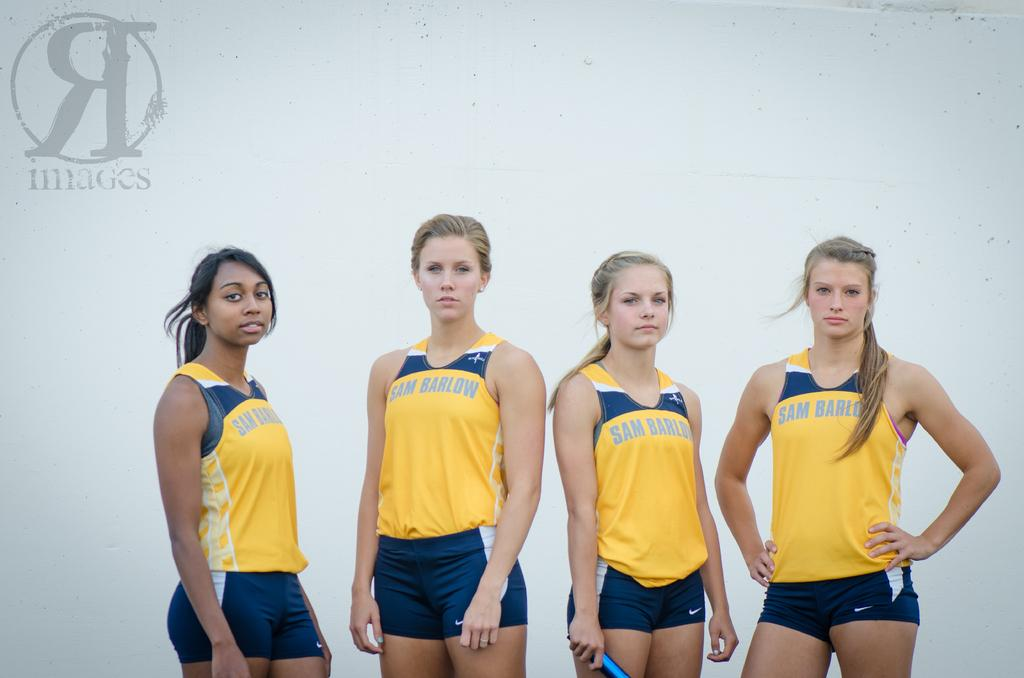Provide a one-sentence caption for the provided image. Four girls wearing uniforms reading Sam Barlow are standing side by side. 